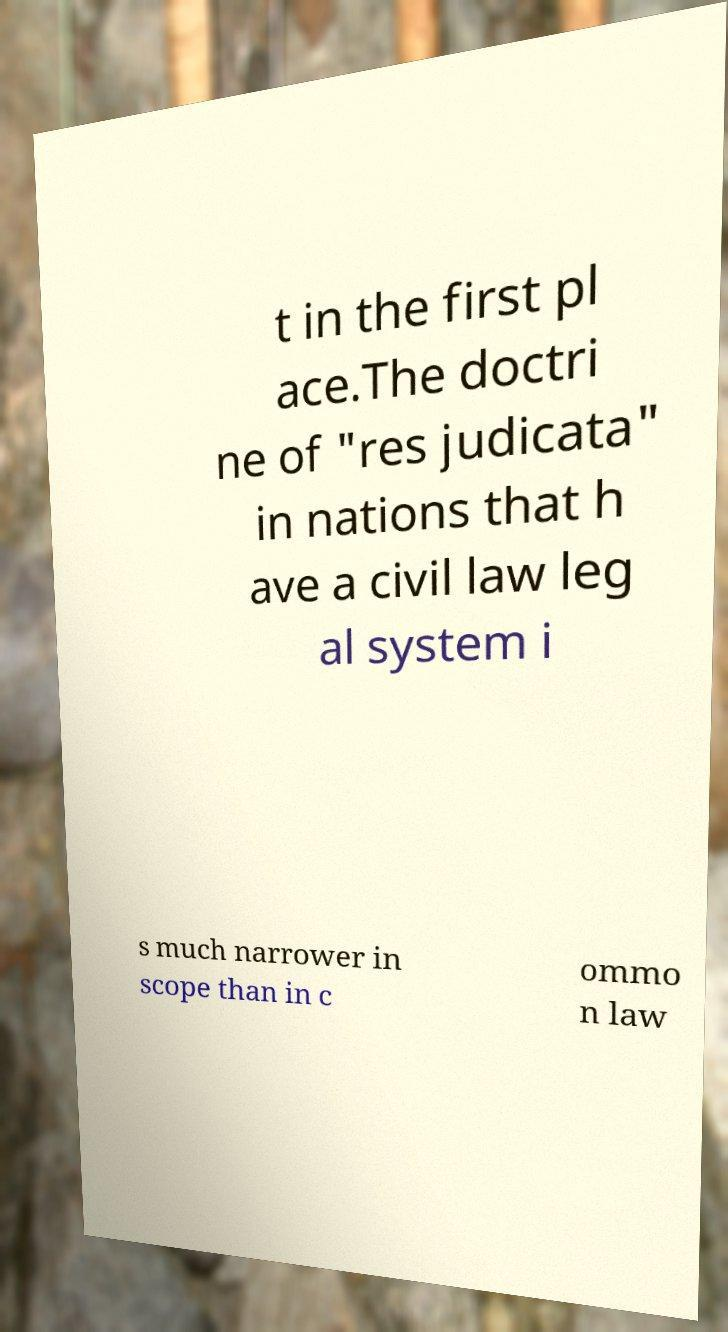Could you extract and type out the text from this image? t in the first pl ace.The doctri ne of "res judicata" in nations that h ave a civil law leg al system i s much narrower in scope than in c ommo n law 